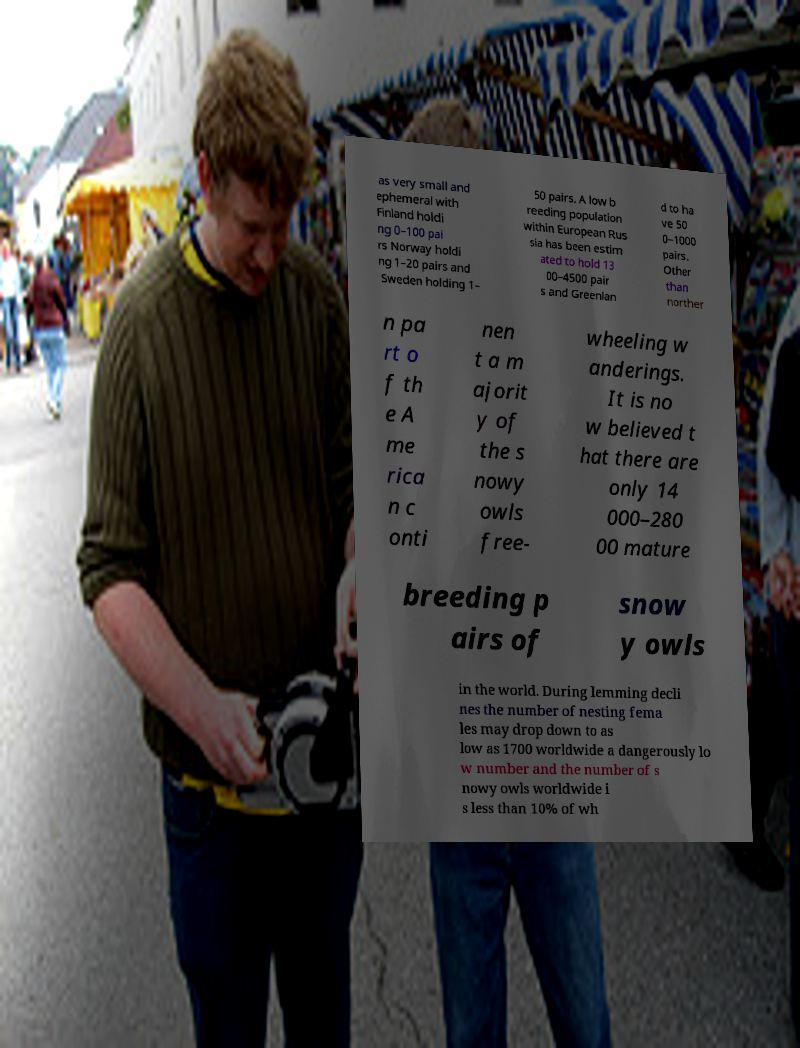Please read and relay the text visible in this image. What does it say? as very small and ephemeral with Finland holdi ng 0–100 pai rs Norway holdi ng 1–20 pairs and Sweden holding 1– 50 pairs. A low b reeding population within European Rus sia has been estim ated to hold 13 00–4500 pair s and Greenlan d to ha ve 50 0–1000 pairs. Other than norther n pa rt o f th e A me rica n c onti nen t a m ajorit y of the s nowy owls free- wheeling w anderings. It is no w believed t hat there are only 14 000–280 00 mature breeding p airs of snow y owls in the world. During lemming decli nes the number of nesting fema les may drop down to as low as 1700 worldwide a dangerously lo w number and the number of s nowy owls worldwide i s less than 10% of wh 